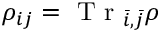Convert formula to latex. <formula><loc_0><loc_0><loc_500><loc_500>{ \rho } _ { i j } = T r _ { \bar { i } , \bar { j } } { \rho }</formula> 